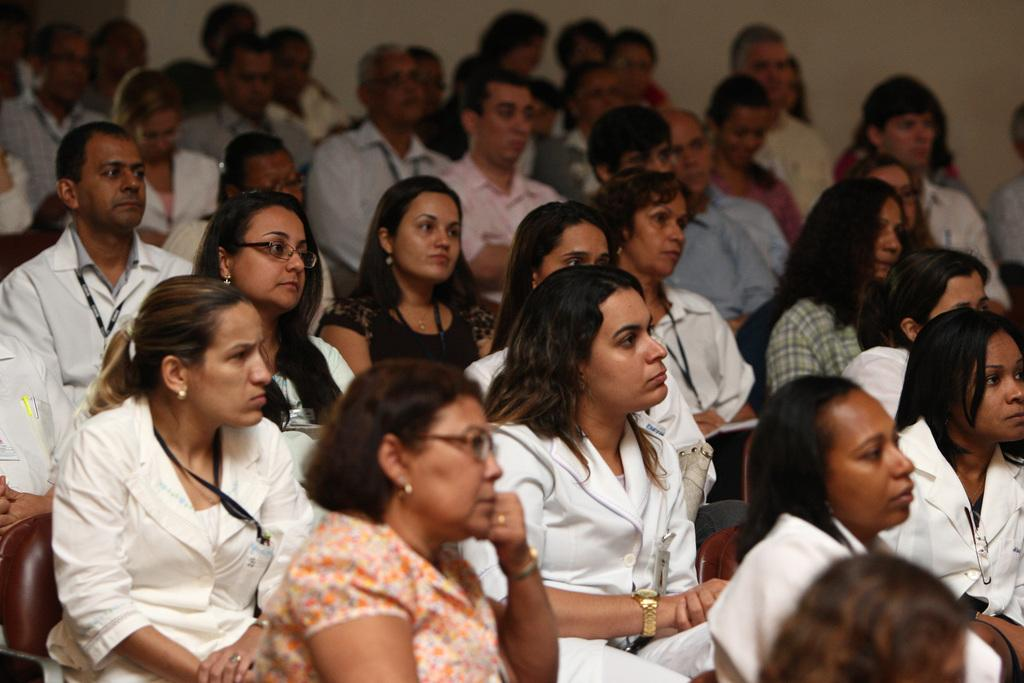What is happening in the image? There is a group of people in the image, and they are sitting. Can you describe the setting of the image? There is a wall in the background of the image. What substance is being shown to the people in the image? There is no substance being shown to the people in the image; they are simply sitting. 